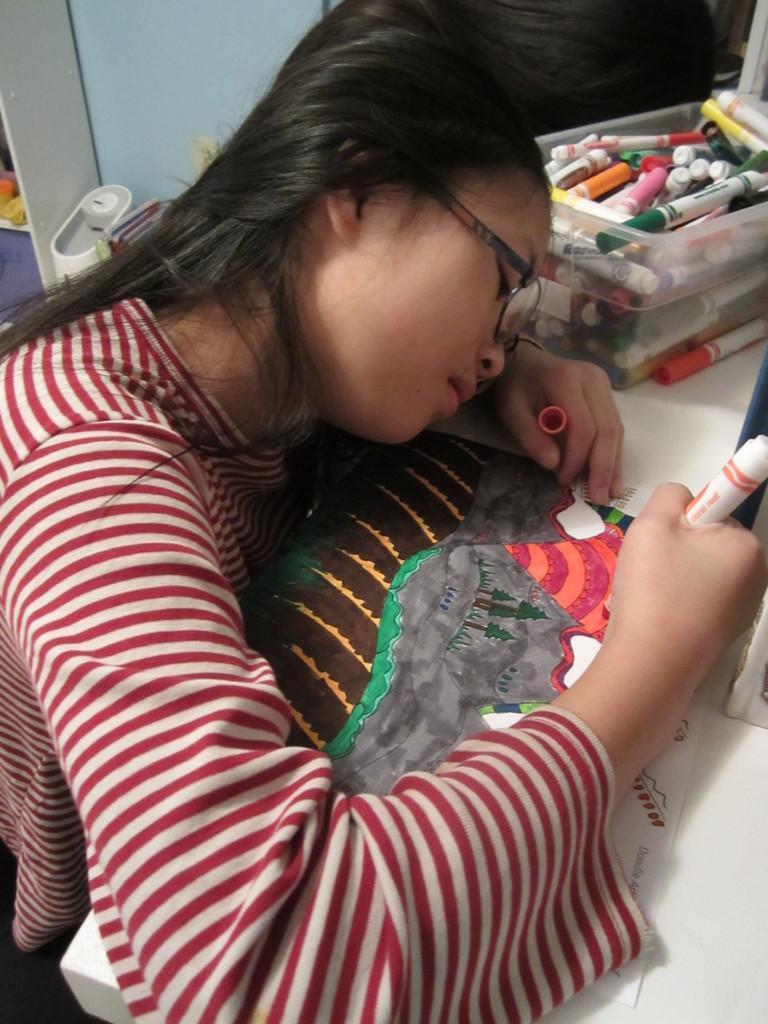In one or two sentences, can you explain what this image depicts? In this image there is a person with spectacles is drawing with a marker on the paper, and there are color markers in a plastic container , and in the background there are some objects. 